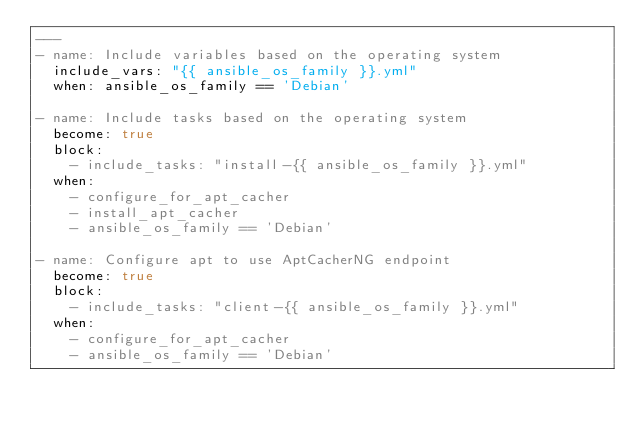<code> <loc_0><loc_0><loc_500><loc_500><_YAML_>---
- name: Include variables based on the operating system
  include_vars: "{{ ansible_os_family }}.yml"
  when: ansible_os_family == 'Debian'

- name: Include tasks based on the operating system
  become: true
  block:
    - include_tasks: "install-{{ ansible_os_family }}.yml"
  when:
    - configure_for_apt_cacher
    - install_apt_cacher
    - ansible_os_family == 'Debian'

- name: Configure apt to use AptCacherNG endpoint
  become: true
  block:
    - include_tasks: "client-{{ ansible_os_family }}.yml"
  when:
    - configure_for_apt_cacher
    - ansible_os_family == 'Debian'
</code> 